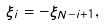Convert formula to latex. <formula><loc_0><loc_0><loc_500><loc_500>\xi _ { i } = - \xi _ { N - i + 1 } ,</formula> 